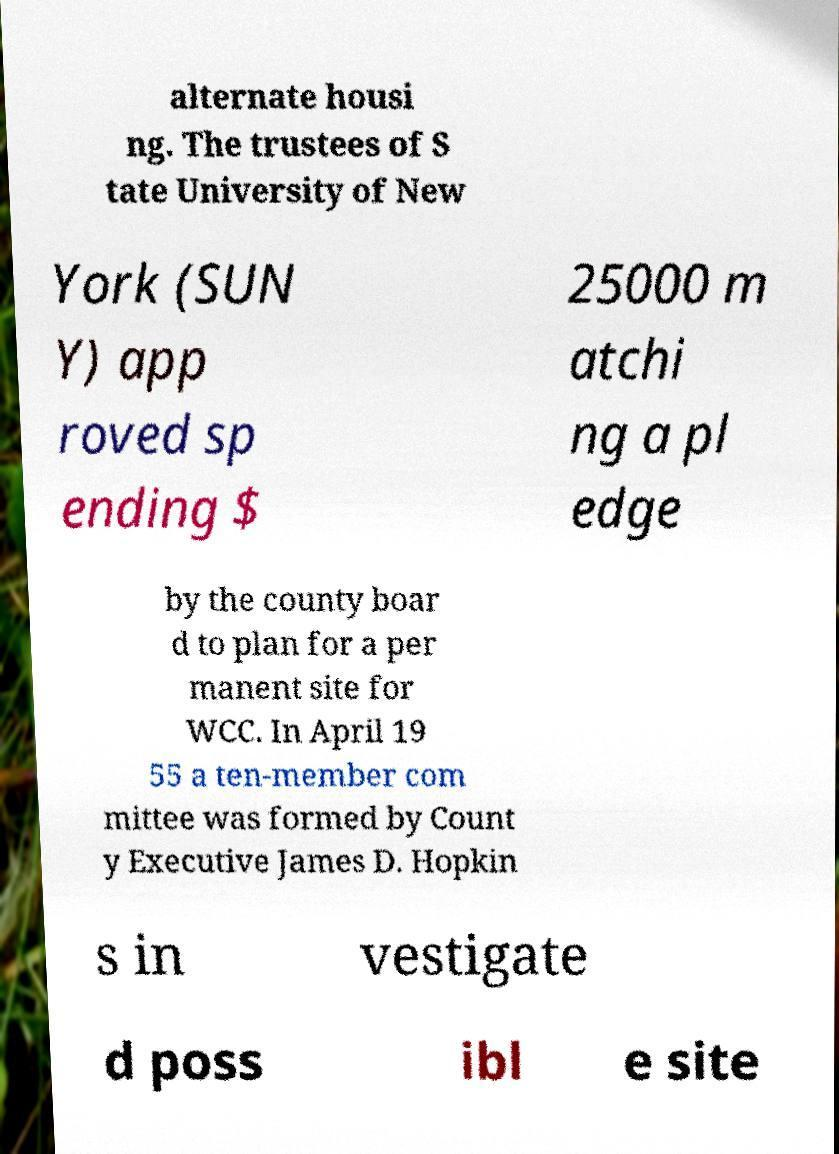Can you read and provide the text displayed in the image?This photo seems to have some interesting text. Can you extract and type it out for me? alternate housi ng. The trustees of S tate University of New York (SUN Y) app roved sp ending $ 25000 m atchi ng a pl edge by the county boar d to plan for a per manent site for WCC. In April 19 55 a ten-member com mittee was formed by Count y Executive James D. Hopkin s in vestigate d poss ibl e site 